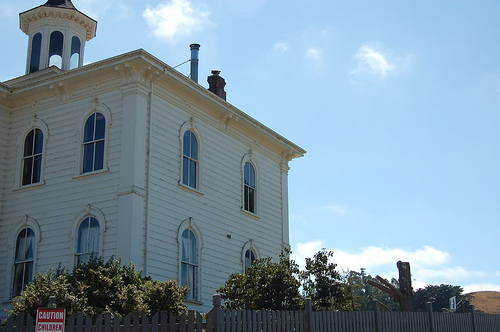<image>
Can you confirm if the building is under the sky? Yes. The building is positioned underneath the sky, with the sky above it in the vertical space. 